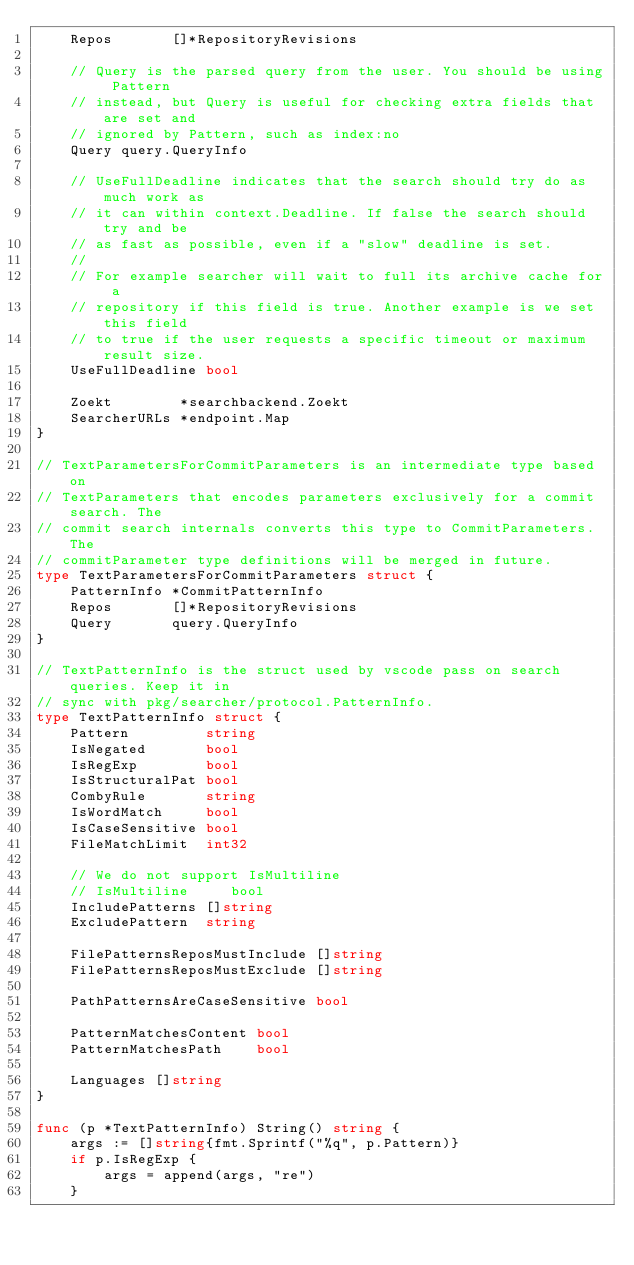<code> <loc_0><loc_0><loc_500><loc_500><_Go_>	Repos       []*RepositoryRevisions

	// Query is the parsed query from the user. You should be using Pattern
	// instead, but Query is useful for checking extra fields that are set and
	// ignored by Pattern, such as index:no
	Query query.QueryInfo

	// UseFullDeadline indicates that the search should try do as much work as
	// it can within context.Deadline. If false the search should try and be
	// as fast as possible, even if a "slow" deadline is set.
	//
	// For example searcher will wait to full its archive cache for a
	// repository if this field is true. Another example is we set this field
	// to true if the user requests a specific timeout or maximum result size.
	UseFullDeadline bool

	Zoekt        *searchbackend.Zoekt
	SearcherURLs *endpoint.Map
}

// TextParametersForCommitParameters is an intermediate type based on
// TextParameters that encodes parameters exclusively for a commit search. The
// commit search internals converts this type to CommitParameters. The
// commitParameter type definitions will be merged in future.
type TextParametersForCommitParameters struct {
	PatternInfo *CommitPatternInfo
	Repos       []*RepositoryRevisions
	Query       query.QueryInfo
}

// TextPatternInfo is the struct used by vscode pass on search queries. Keep it in
// sync with pkg/searcher/protocol.PatternInfo.
type TextPatternInfo struct {
	Pattern         string
	IsNegated       bool
	IsRegExp        bool
	IsStructuralPat bool
	CombyRule       string
	IsWordMatch     bool
	IsCaseSensitive bool
	FileMatchLimit  int32

	// We do not support IsMultiline
	// IsMultiline     bool
	IncludePatterns []string
	ExcludePattern  string

	FilePatternsReposMustInclude []string
	FilePatternsReposMustExclude []string

	PathPatternsAreCaseSensitive bool

	PatternMatchesContent bool
	PatternMatchesPath    bool

	Languages []string
}

func (p *TextPatternInfo) String() string {
	args := []string{fmt.Sprintf("%q", p.Pattern)}
	if p.IsRegExp {
		args = append(args, "re")
	}</code> 